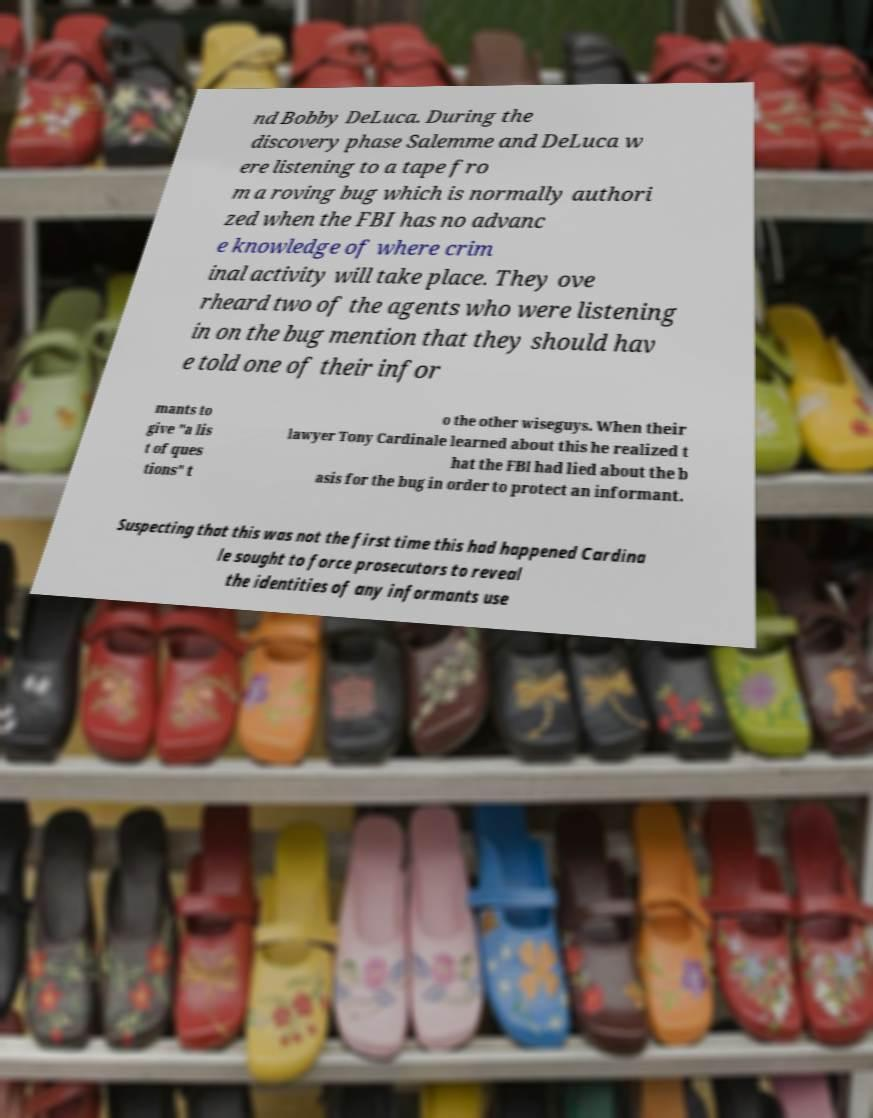I need the written content from this picture converted into text. Can you do that? nd Bobby DeLuca. During the discovery phase Salemme and DeLuca w ere listening to a tape fro m a roving bug which is normally authori zed when the FBI has no advanc e knowledge of where crim inal activity will take place. They ove rheard two of the agents who were listening in on the bug mention that they should hav e told one of their infor mants to give "a lis t of ques tions" t o the other wiseguys. When their lawyer Tony Cardinale learned about this he realized t hat the FBI had lied about the b asis for the bug in order to protect an informant. Suspecting that this was not the first time this had happened Cardina le sought to force prosecutors to reveal the identities of any informants use 